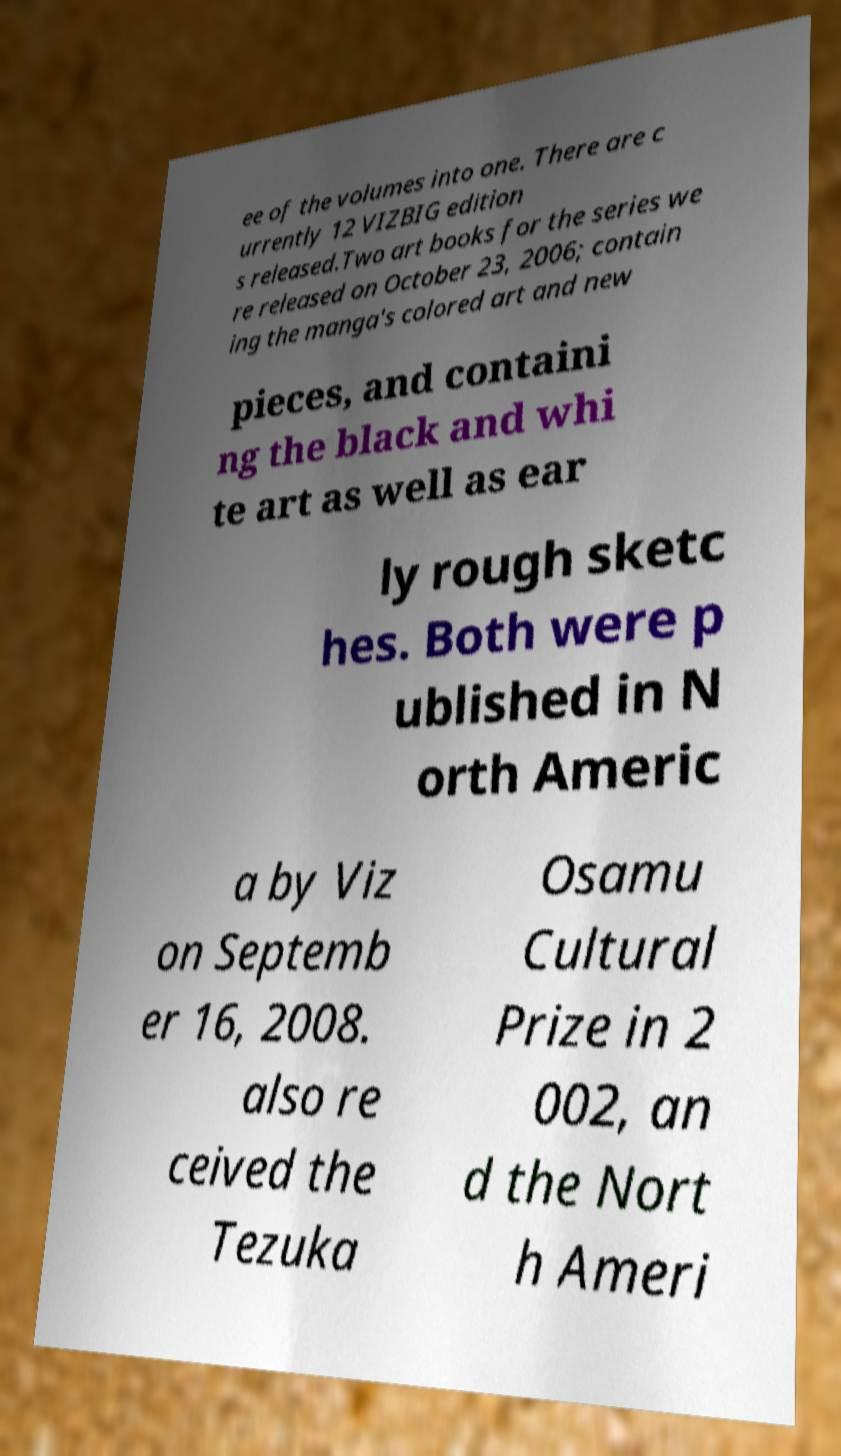Can you accurately transcribe the text from the provided image for me? ee of the volumes into one. There are c urrently 12 VIZBIG edition s released.Two art books for the series we re released on October 23, 2006; contain ing the manga's colored art and new pieces, and containi ng the black and whi te art as well as ear ly rough sketc hes. Both were p ublished in N orth Americ a by Viz on Septemb er 16, 2008. also re ceived the Tezuka Osamu Cultural Prize in 2 002, an d the Nort h Ameri 